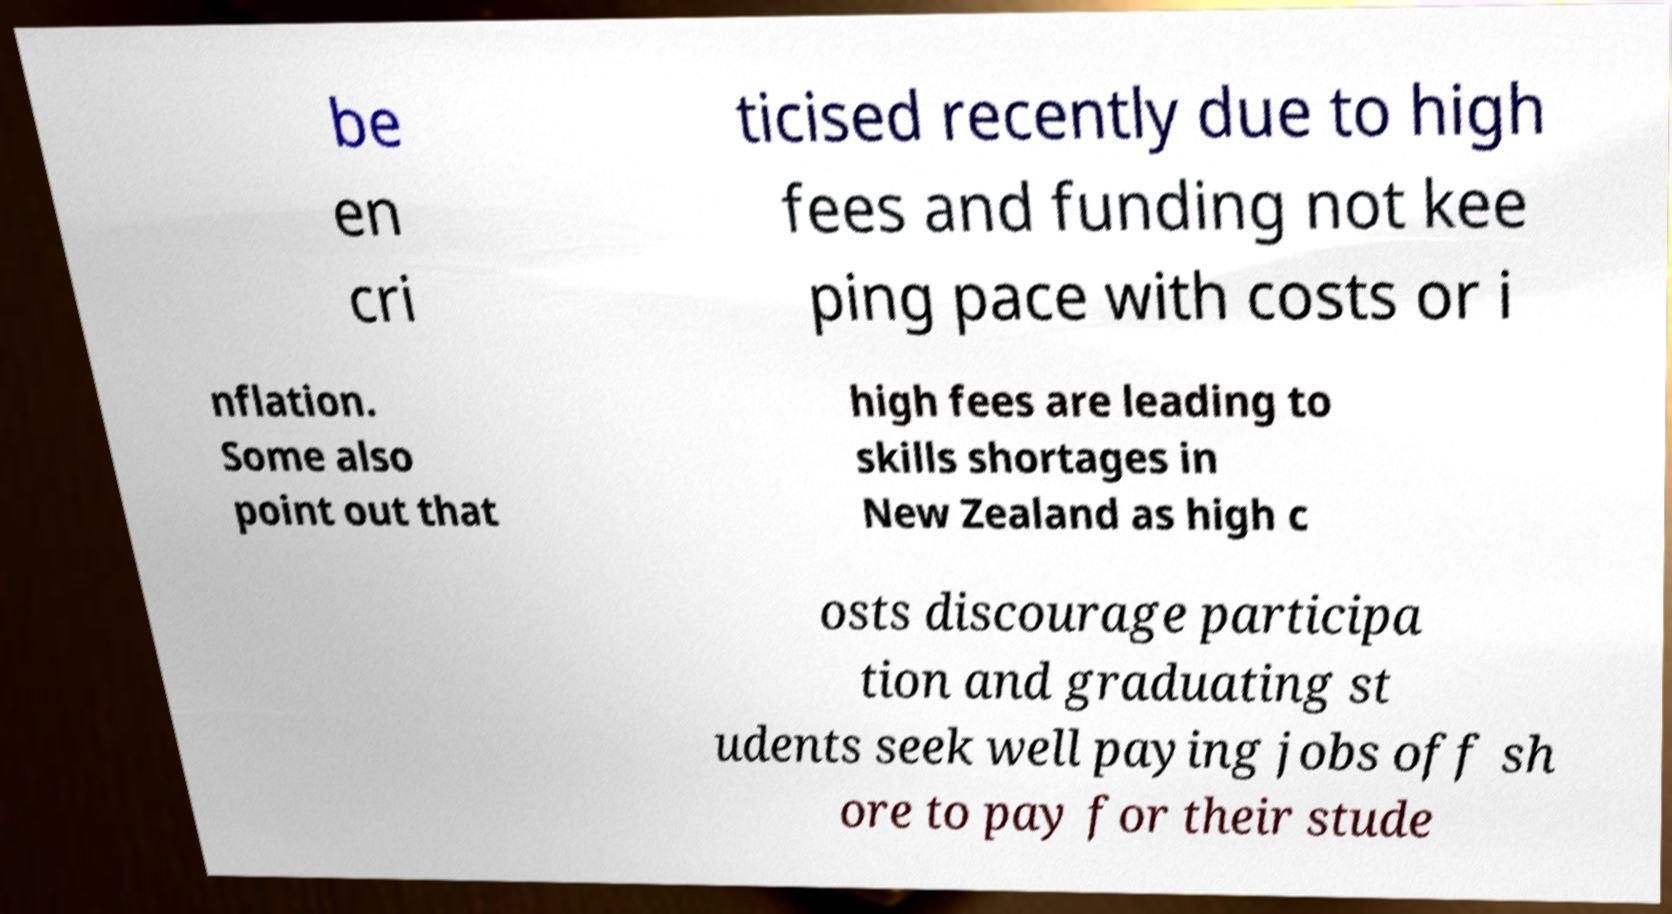I need the written content from this picture converted into text. Can you do that? be en cri ticised recently due to high fees and funding not kee ping pace with costs or i nflation. Some also point out that high fees are leading to skills shortages in New Zealand as high c osts discourage participa tion and graduating st udents seek well paying jobs off sh ore to pay for their stude 